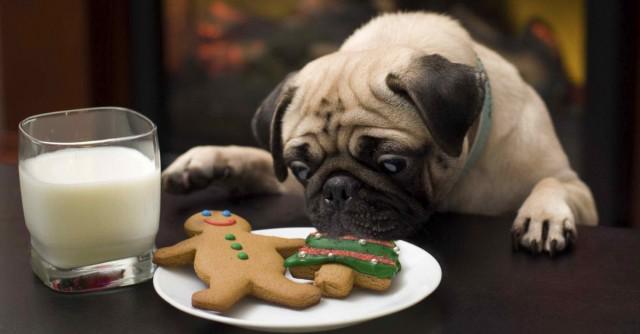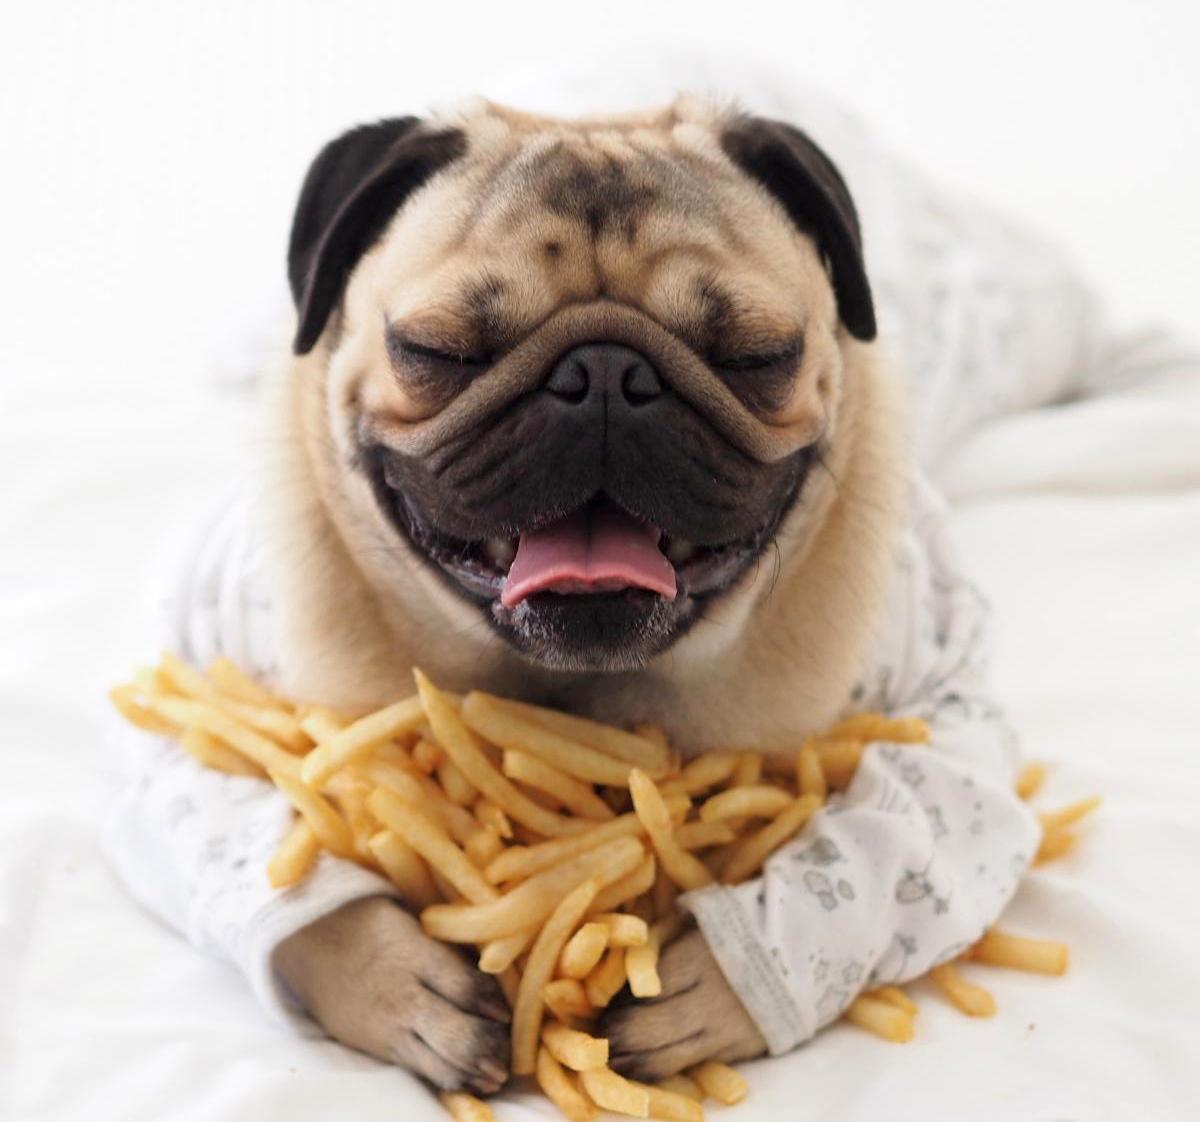The first image is the image on the left, the second image is the image on the right. For the images shown, is this caption "The dog in the image on the left is sitting before a white plate of food." true? Answer yes or no. Yes. 